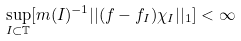Convert formula to latex. <formula><loc_0><loc_0><loc_500><loc_500>\sup _ { I \subset \mathbb { T } } [ m ( I ) ^ { - 1 } | | ( f - f _ { I } ) \chi _ { I } | | _ { 1 } ] < \infty</formula> 